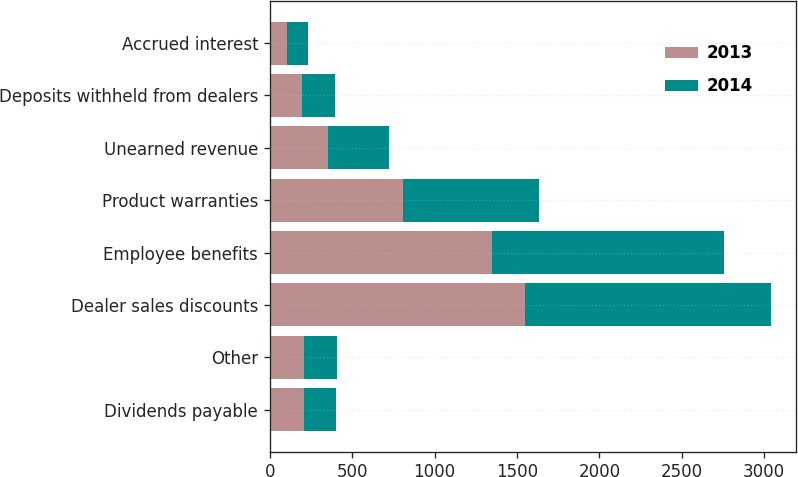<chart> <loc_0><loc_0><loc_500><loc_500><stacked_bar_chart><ecel><fcel>Dividends payable<fcel>Other<fcel>Dealer sales discounts<fcel>Employee benefits<fcel>Product warranties<fcel>Unearned revenue<fcel>Deposits withheld from dealers<fcel>Accrued interest<nl><fcel>2013<fcel>210<fcel>208<fcel>1551<fcel>1350<fcel>809<fcel>355<fcel>196<fcel>103<nl><fcel>2014<fcel>192<fcel>197<fcel>1491<fcel>1408<fcel>822<fcel>368<fcel>197<fcel>130<nl></chart> 